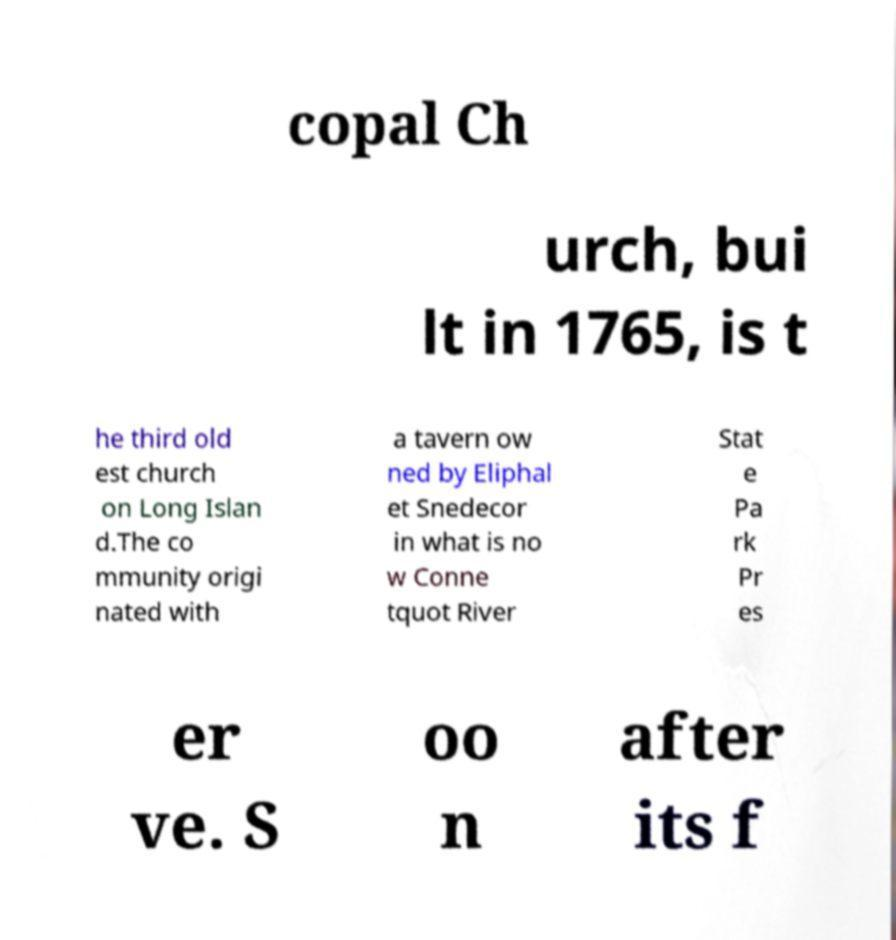There's text embedded in this image that I need extracted. Can you transcribe it verbatim? copal Ch urch, bui lt in 1765, is t he third old est church on Long Islan d.The co mmunity origi nated with a tavern ow ned by Eliphal et Snedecor in what is no w Conne tquot River Stat e Pa rk Pr es er ve. S oo n after its f 